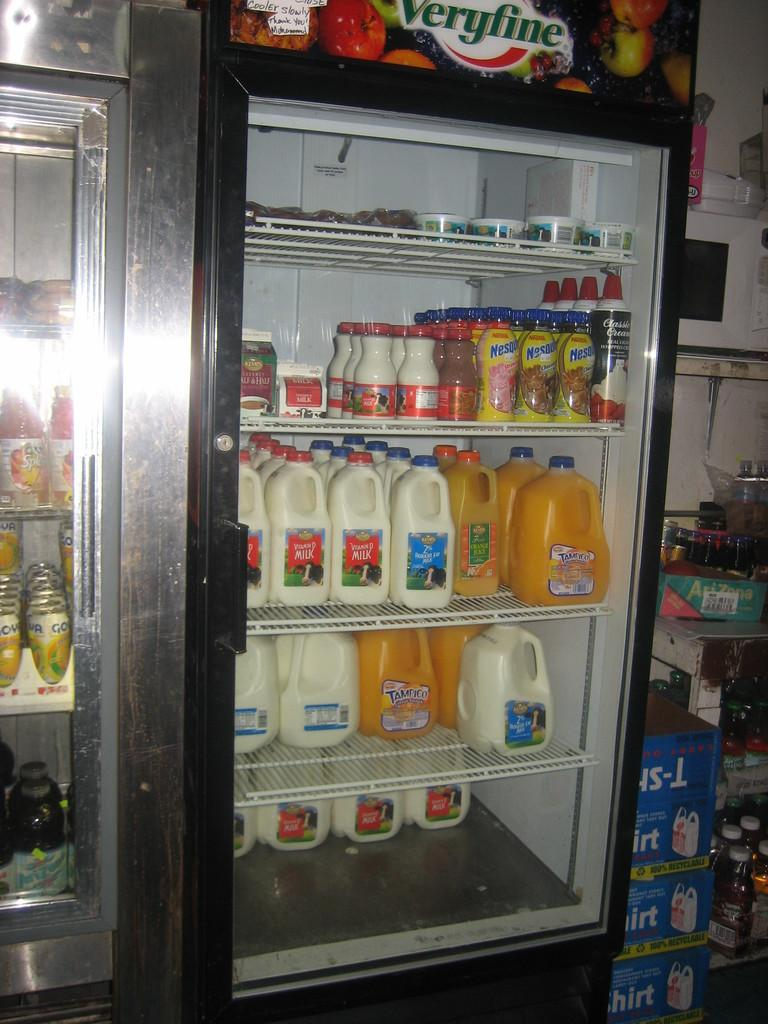<image>
Summarize the visual content of the image. A cooler containing milk, whipped cream orange juice and Nestle drinks. 